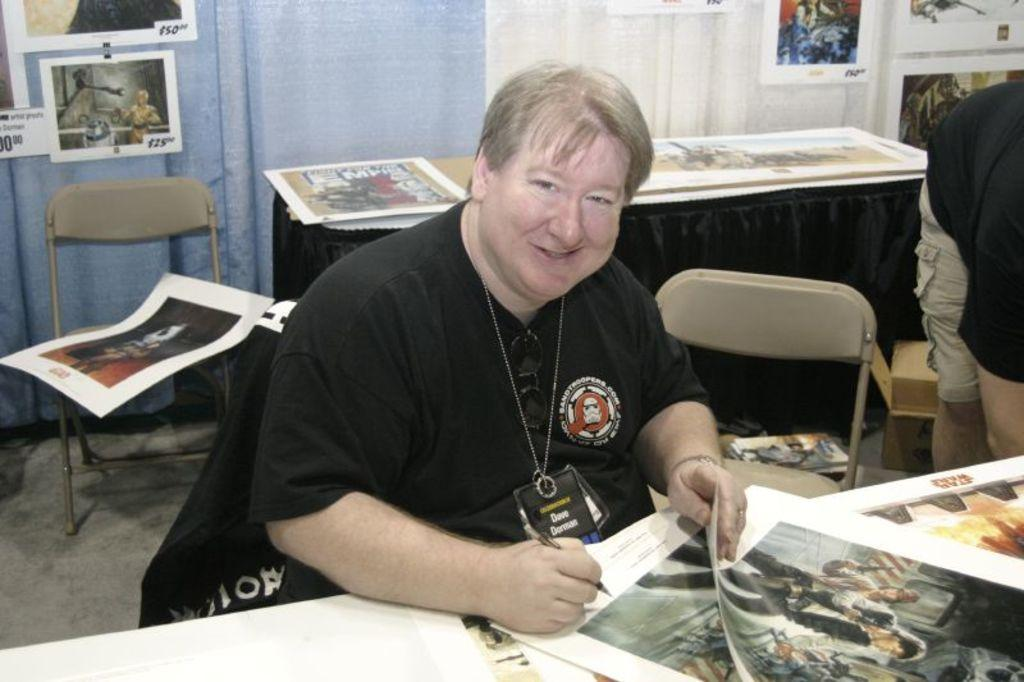Who is present in the image? There is a man in the image. What is the man wearing? The man is wearing a white shirt. What is the man doing in the image? The man is sitting on a chair and holding a pen. What is on the table in front of the man? There is a paper on the table in front of the man. What is on the table behind the man? There are charts on the table behind the man. Where are the kittens playing in the image? There are no kittens present in the image. What type of sweater is the man wearing in the image? The man is not wearing a sweater in the image; he is wearing a white shirt. 